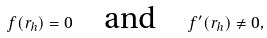<formula> <loc_0><loc_0><loc_500><loc_500>f ( r _ { h } ) = 0 \quad \text {and} \quad f ^ { \prime } ( r _ { h } ) \neq 0 ,</formula> 